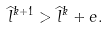Convert formula to latex. <formula><loc_0><loc_0><loc_500><loc_500>\widehat { l } ^ { k + 1 } > \widehat { l } ^ { k } + e .</formula> 